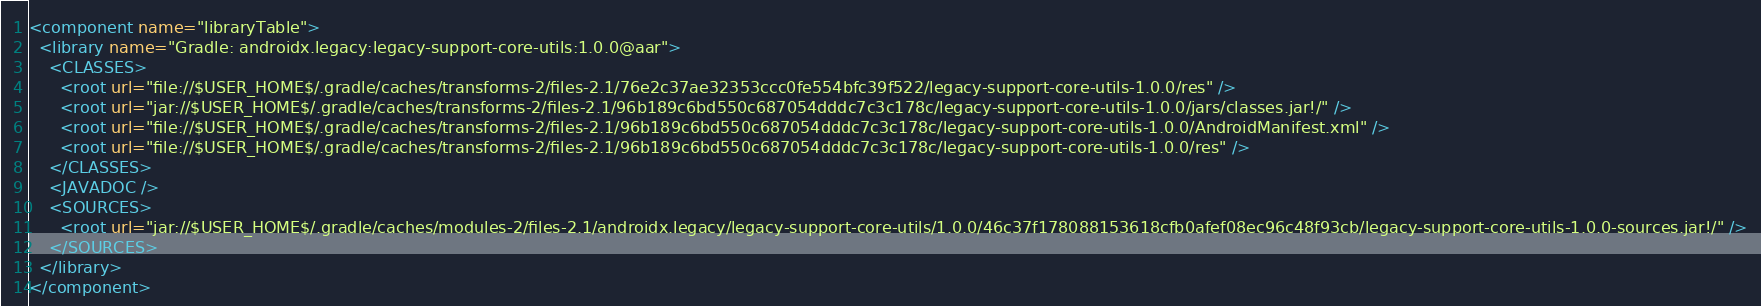<code> <loc_0><loc_0><loc_500><loc_500><_XML_><component name="libraryTable">
  <library name="Gradle: androidx.legacy:legacy-support-core-utils:1.0.0@aar">
    <CLASSES>
      <root url="file://$USER_HOME$/.gradle/caches/transforms-2/files-2.1/76e2c37ae32353ccc0fe554bfc39f522/legacy-support-core-utils-1.0.0/res" />
      <root url="jar://$USER_HOME$/.gradle/caches/transforms-2/files-2.1/96b189c6bd550c687054dddc7c3c178c/legacy-support-core-utils-1.0.0/jars/classes.jar!/" />
      <root url="file://$USER_HOME$/.gradle/caches/transforms-2/files-2.1/96b189c6bd550c687054dddc7c3c178c/legacy-support-core-utils-1.0.0/AndroidManifest.xml" />
      <root url="file://$USER_HOME$/.gradle/caches/transforms-2/files-2.1/96b189c6bd550c687054dddc7c3c178c/legacy-support-core-utils-1.0.0/res" />
    </CLASSES>
    <JAVADOC />
    <SOURCES>
      <root url="jar://$USER_HOME$/.gradle/caches/modules-2/files-2.1/androidx.legacy/legacy-support-core-utils/1.0.0/46c37f178088153618cfb0afef08ec96c48f93cb/legacy-support-core-utils-1.0.0-sources.jar!/" />
    </SOURCES>
  </library>
</component></code> 